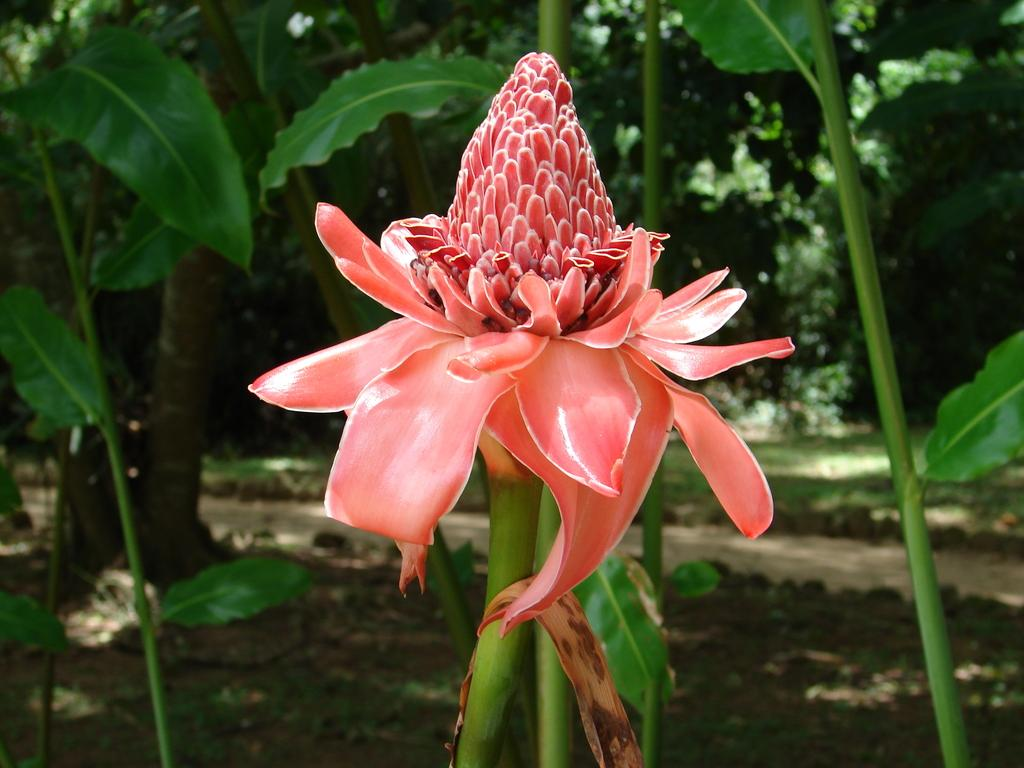What type of vegetation can be seen in the image? There are flowers, plants, and trees in the image. Can you describe the different types of vegetation present? The image contains flowers, plants, and trees. What is visible in the background of the image? There are trees in the background of the image. What type of kettle is used to make a decision in the image? There is no kettle or decision-making process depicted in the image; it features flowers, plants, and trees. Can you see a bat flying in the image? There is no bat present in the image. 